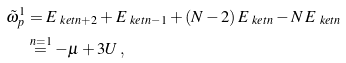Convert formula to latex. <formula><loc_0><loc_0><loc_500><loc_500>\tilde { \omega } _ { p } ^ { 1 } & = E _ { \ k e t { n + 2 } } + E _ { \ k e t { n - 1 } } + ( N - 2 ) \, E _ { \ k e t { n } } - N \, E _ { \ k e t { n } } \\ & \stackrel { n = 1 } { = } - \mu + 3 U \, ,</formula> 